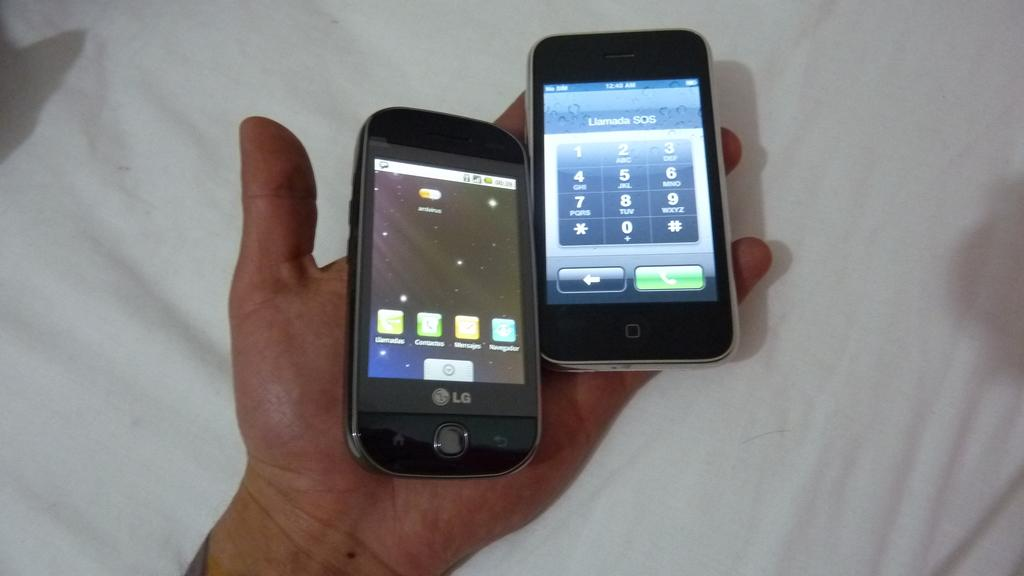<image>
Provide a brief description of the given image. two cellphones in one hand, one an LG and the other an iphone 